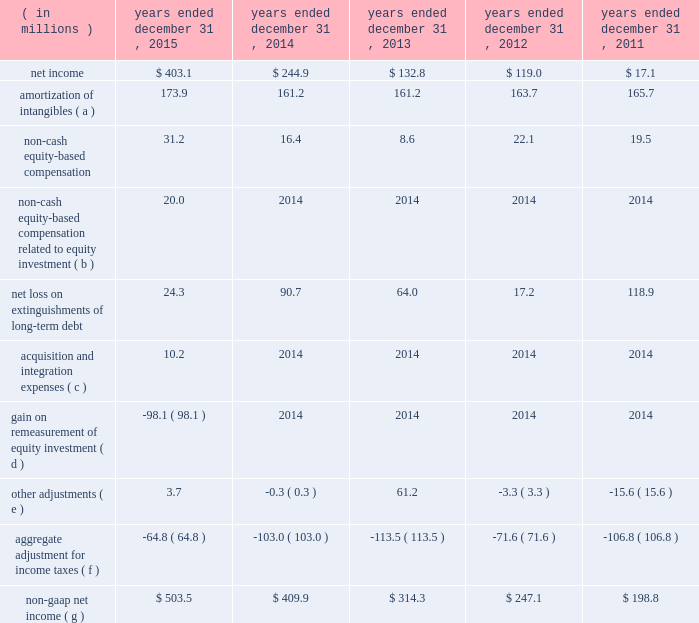Table of contents ( e ) other adjustments primarily include certain historical retention costs , unusual , non-recurring litigation matters , secondary-offering-related expenses and expenses related to the consolidation of office locations north of chicago .
During the year ended december 31 , 2013 , we recorded ipo- and secondary-offering related expenses of $ 75.0 million .
For additional information on the ipo- and secondary-offering related expenses , see note 10 ( stockholder 2019s equity ) to the accompanying consolidated financial statements .
( f ) includes the impact of consolidating five months for the year ended december 31 , 2015 of kelway 2019s financial results .
( 4 ) non-gaap net income excludes , among other things , charges related to the amortization of acquisition-related intangible assets , non-cash equity-based compensation , acquisition and integration expenses , and gains and losses from the extinguishment of long-term debt .
Non-gaap net income is considered a non-gaap financial measure .
Generally , a non-gaap financial measure is a numerical measure of a company 2019s performance , financial position or cash flows that either excludes or includes amounts that are not normally included or excluded in the most directly comparable measure calculated and presented in accordance with gaap .
Non-gaap measures used by us may differ from similar measures used by other companies , even when similar terms are used to identify such measures .
We believe that non-gaap net income provides meaningful information regarding our operating performance and cash flows including our ability to meet our future debt service , capital expenditures and working capital requirements .
The following unaudited table sets forth a reconciliation of net income to non-gaap net income for the periods presented: .
Acquisition and integration expenses ( c ) 10.2 2014 2014 2014 2014 gain on remeasurement of equity investment ( d ) ( 98.1 ) 2014 2014 2014 2014 other adjustments ( e ) 3.7 ( 0.3 ) 61.2 ( 3.3 ) ( 15.6 ) aggregate adjustment for income taxes ( f ) ( 64.8 ) ( 103.0 ) ( 113.5 ) ( 71.6 ) ( 106.8 ) non-gaap net income ( g ) $ 503.5 $ 409.9 $ 314.3 $ 247.1 $ 198.8 ( a ) includes amortization expense for acquisition-related intangible assets , primarily customer relationships , customer contracts and trade names .
( b ) represents our 35% ( 35 % ) share of an expense related to certain equity awards granted by one of the sellers to kelway coworkers in july 2015 prior to our acquisition of kelway .
( c ) primarily includes expenses related to the acquisition of kelway .
( d ) represents the gain resulting from the remeasurement of our previously held 35% ( 35 % ) equity investment to fair value upon the completion of the acquisition of kelway .
( e ) primarily includes expenses related to the consolidation of office locations north of chicago and secondary- offering-related expenses .
Amount in 2013 primarily relates to ipo- and secondary-offering related expenses .
( f ) based on a normalized effective tax rate of 38.0% ( 38.0 % ) ( 39.0% ( 39.0 % ) prior to the kelway acquisition ) , except for the non- cash equity-based compensation from our equity investment and the gain resulting from the remeasurement of our previously held 35% ( 35 % ) equity investment to fair value upon the completion of the acquisition of kelway , which were tax effected at a rate of 35.4% ( 35.4 % ) .
The aggregate adjustment for income taxes also includes a $ 4.0 million deferred tax benefit recorded during the three months and year ended december 31 , 2015 as a result of a tax rate reduction in the united kingdom and additional tax expense during the year ended december 31 , 2015 of $ 3.3 million as a result of recording withholding tax on the unremitted earnings of our canadian subsidiary .
Additionally , note that certain acquisition costs are non-deductible. .
If stock compensation were not an expense , what would 2015 net income have been? 
Computations: ((403.1 + 31.2) * 1000000)
Answer: 434300000.0. 